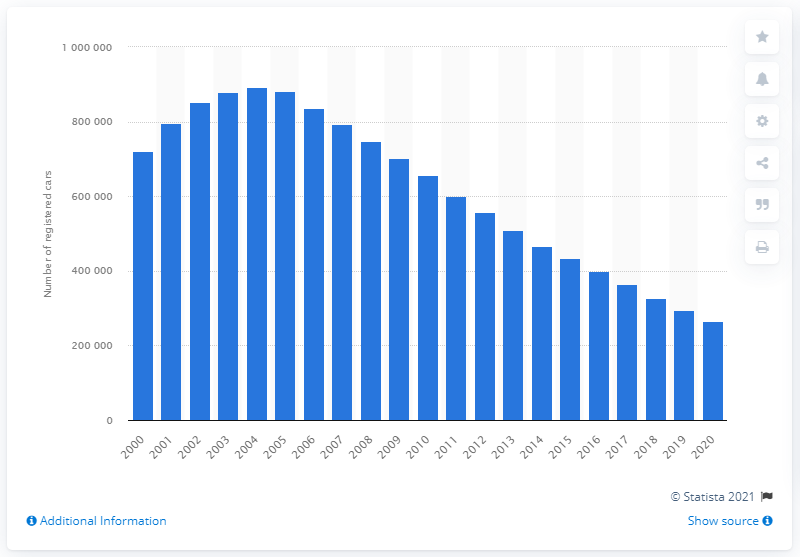Outline some significant characteristics in this image. The number of Ford Mondeo cars began to decline in 2006. In the year 2000, a total of 720,000 Ford Mondeo cars were registered in Great Britain. 